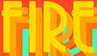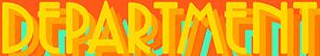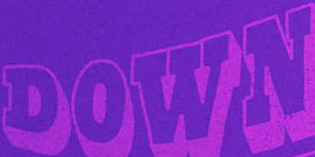What words are shown in these images in order, separated by a semicolon? FIRE; DEPARTMENT; DOWN 